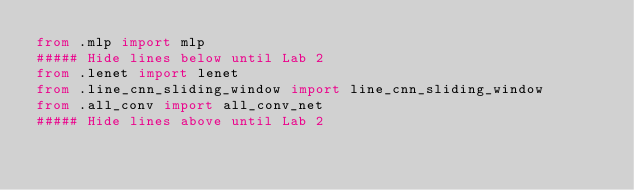Convert code to text. <code><loc_0><loc_0><loc_500><loc_500><_Python_>from .mlp import mlp
##### Hide lines below until Lab 2
from .lenet import lenet
from .line_cnn_sliding_window import line_cnn_sliding_window
from .all_conv import all_conv_net
##### Hide lines above until Lab 2

</code> 